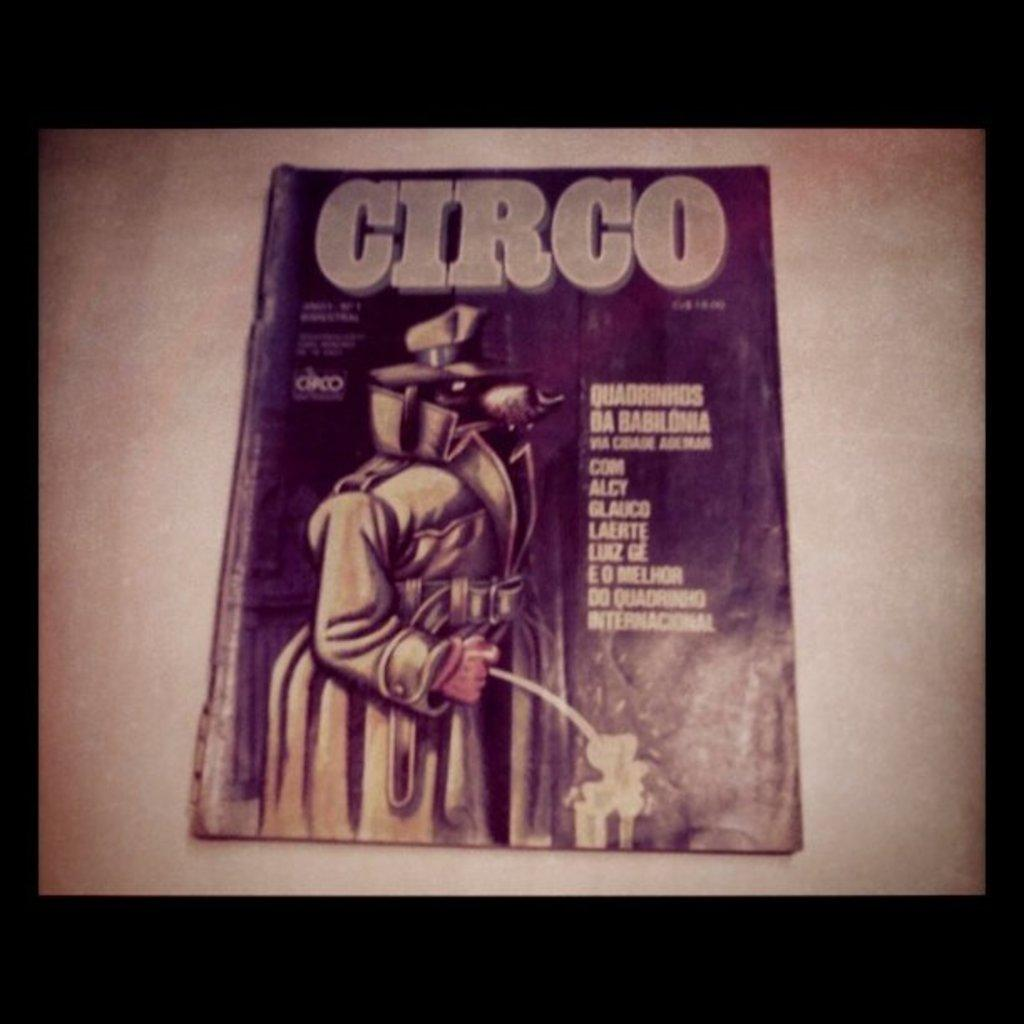<image>
Relay a brief, clear account of the picture shown. A picture of an old book titled circo featuring a man in a trenchcoat and fedora. 